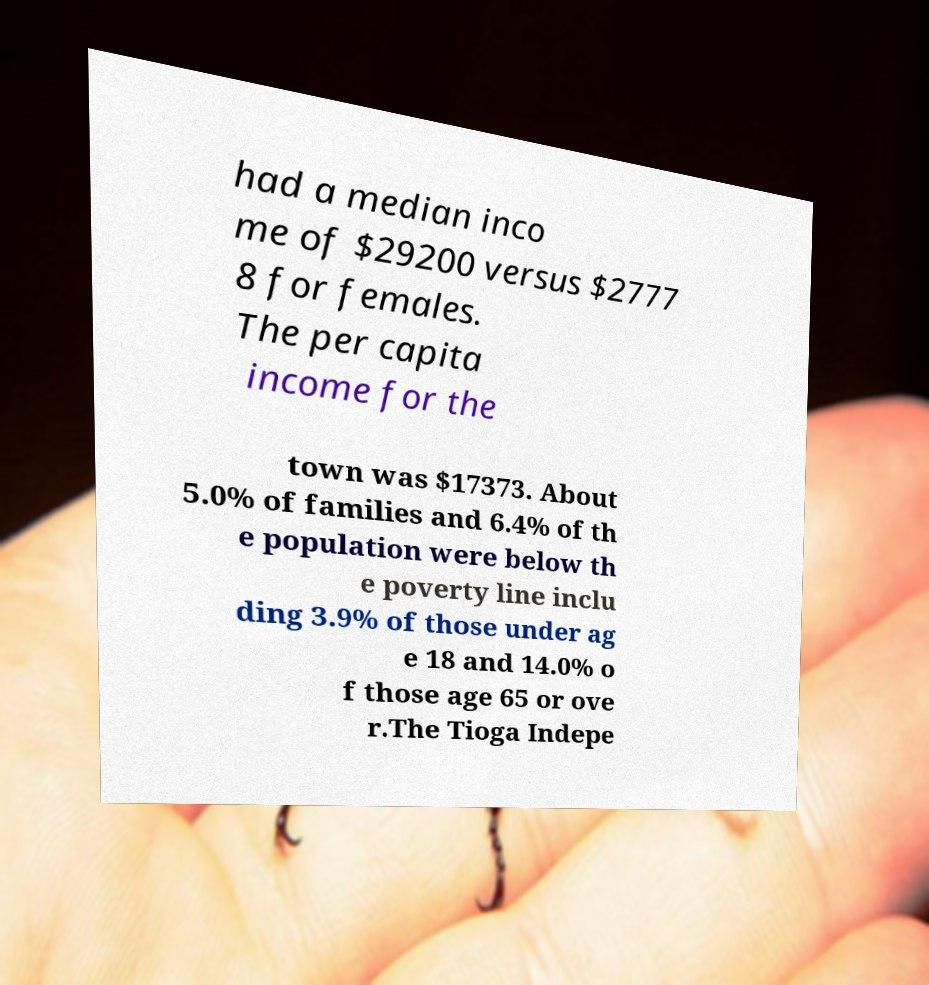For documentation purposes, I need the text within this image transcribed. Could you provide that? had a median inco me of $29200 versus $2777 8 for females. The per capita income for the town was $17373. About 5.0% of families and 6.4% of th e population were below th e poverty line inclu ding 3.9% of those under ag e 18 and 14.0% o f those age 65 or ove r.The Tioga Indepe 